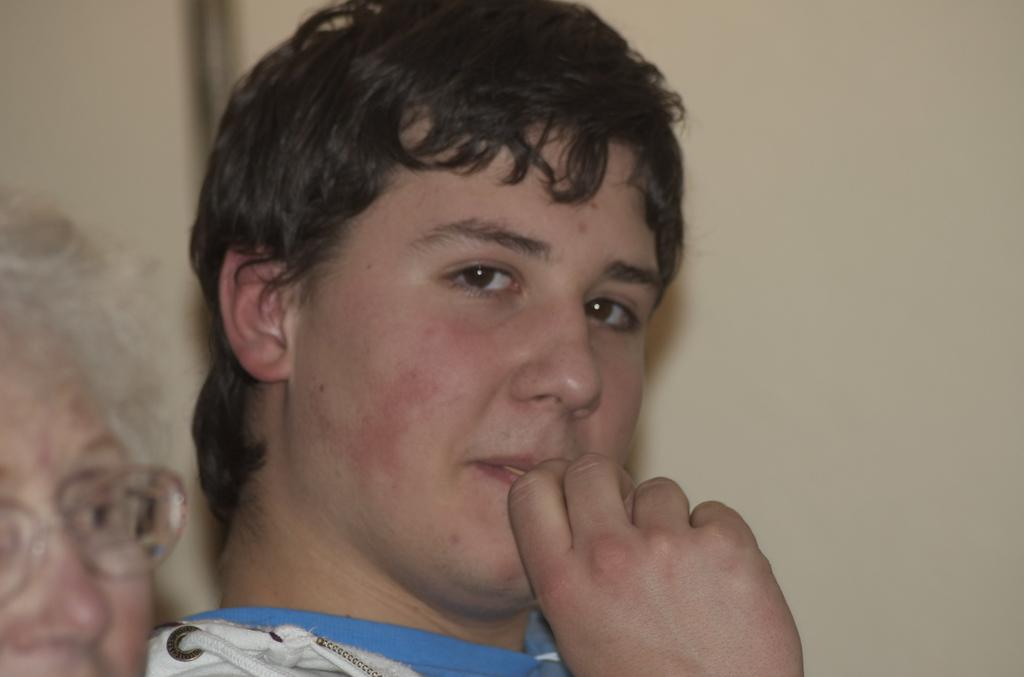Who is present in the image? There is a man and another person with spectacles in the image. Can you describe the person with spectacles? The person with spectacles is on the left side of the image. What can be seen in the background of the image? There is a wall in the background of the image. What direction is the circle moving in the image? There is no circle present in the image, so it cannot be determined how it would move. 